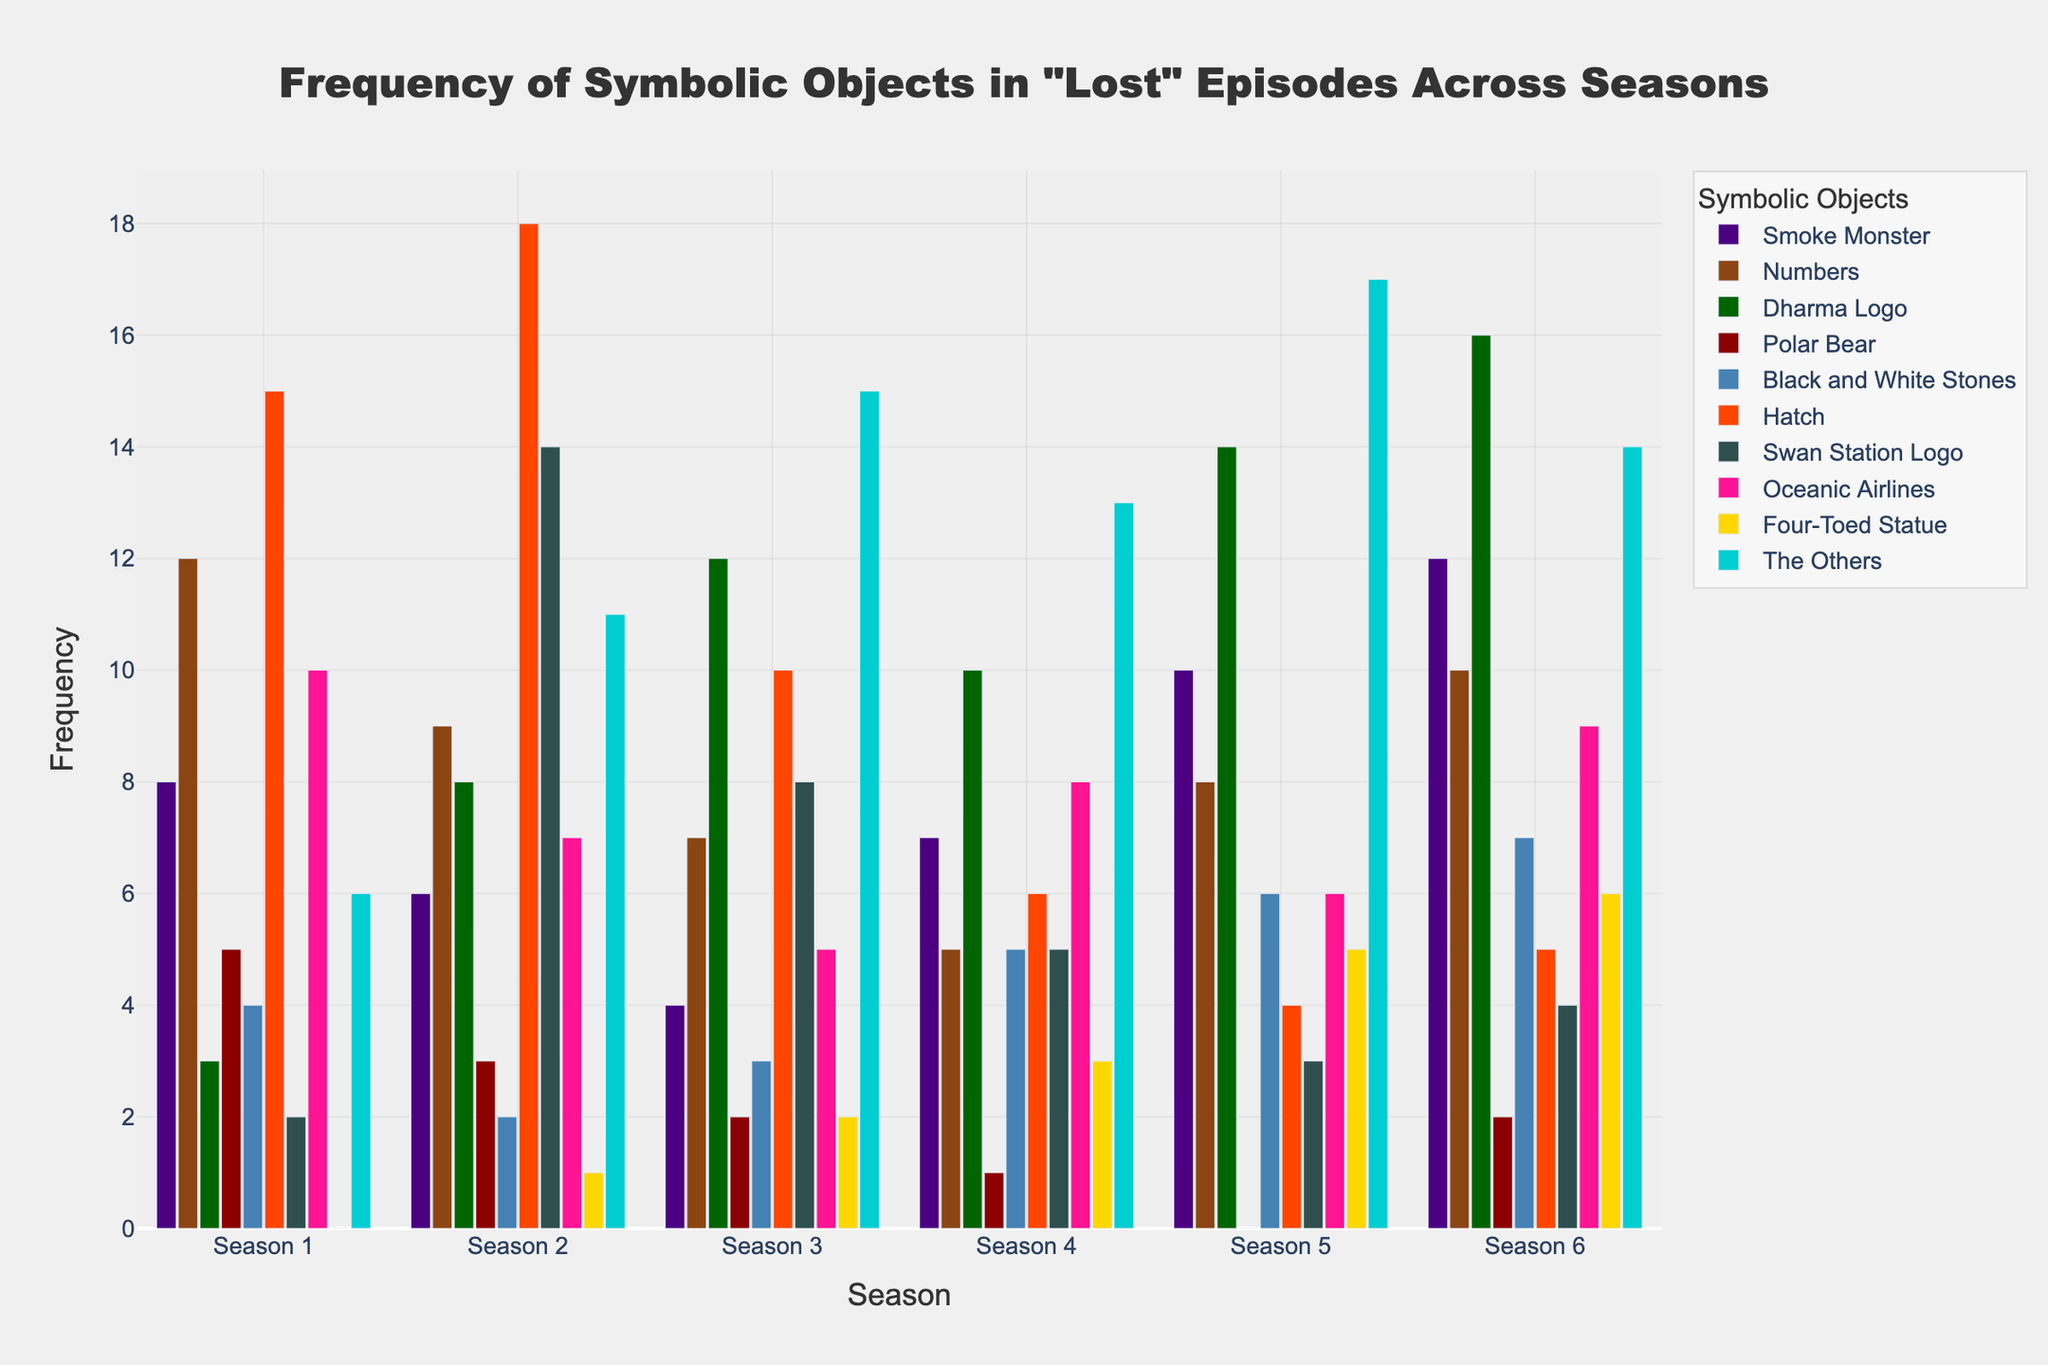Which symbolic object appeared the most in Season 3? Look at the bar heights for Season 3 and find the tallest one. The bar for "The Others" is the tallest.
Answer: The Others How did the frequency of the Smoke Monster change from Season 2 to Season 5? Subtract the number of appearances of the Smoke Monster in Season 2 from its appearances in Season 5 (10 - 6).
Answer: Increased by 4 Which season had the highest total frequency of symbolic objects? Sum up the frequencies for all symbolic objects in each season and compare the totals. Season 6 has the highest sum (85).
Answer: Season 6 What is the average frequency of the Numbers across all seasons? Add up the frequencies of the Numbers from all seasons (12+9+7+5+8+10 = 51), then divide by the number of seasons (6).
Answer: 8.5 Compare the frequency of the Dharma Logo in Season 1 and Season 4. Which season had more appearances? Compare the bar heights for the Dharma Logo in Season 1 (3) and Season 4 (10).
Answer: Season 4 Which symbolic object has the highest difference in frequency between Season 3 and Season 5? Calculate the absolute differences between Season 3 and Season 5 frequencies for all objects and find the maximum difference. The difference for the Dharma Logo is the highest (14 - 12 = 2).
Answer: Dharma Logo What is the ratio of appearances of the Hatch in Season 1 to Season 3? Divide the frequency of the Hatch in Season 1 (15) by its frequency in Season 3 (10). Simplify the ratio.
Answer: 3:2 Which season had the lowest frequency of the Four-Toed Statue? Look at the bar heights for the Four-Toed Statue across all seasons and find the smallest one.
Answer: Season 4 What is the combined frequency of the Oceanic Airlines and Swan Station Logo across all seasons? Sum up the frequencies for Oceanic Airlines (10+7+5+8+6+9) and Swan Station Logo (2+14+8+5+3+4), then add both sums together. The total is 45 + 36 = 81.
Answer: 81 In which season did the frequency of the Others peak? Look at the bar heights for the Others across all seasons and find the peak. Season 5 has the highest bar.
Answer: Season 5 